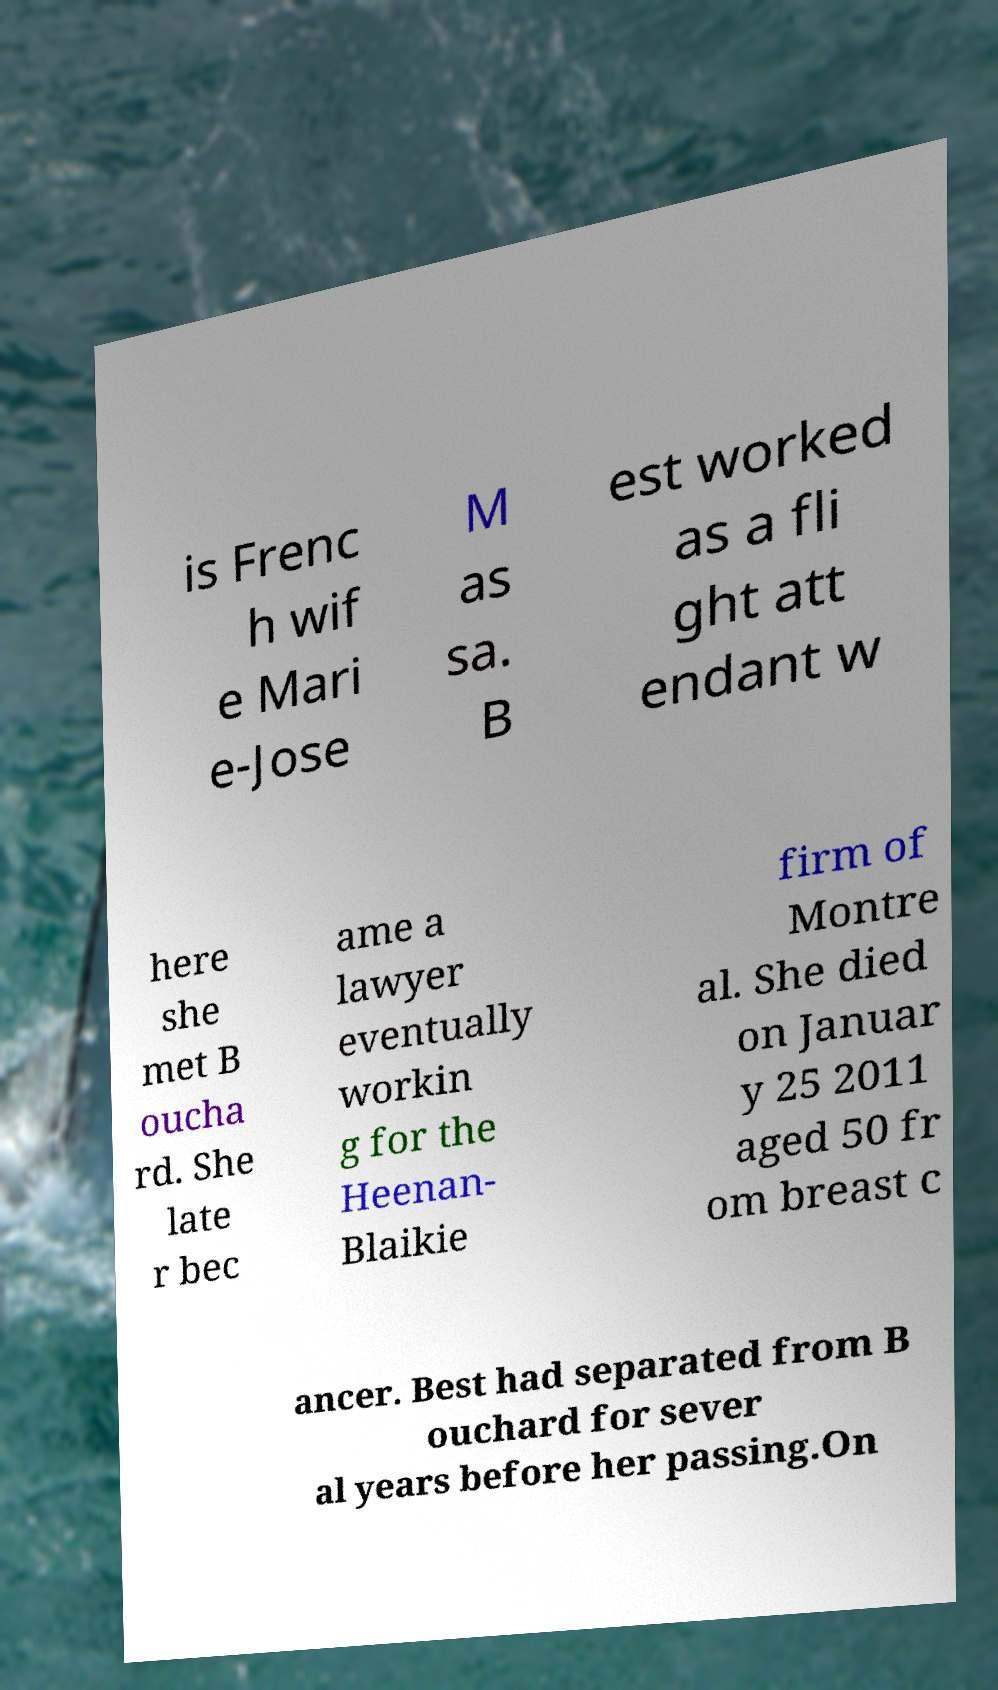Could you extract and type out the text from this image? is Frenc h wif e Mari e-Jose M as sa. B est worked as a fli ght att endant w here she met B oucha rd. She late r bec ame a lawyer eventually workin g for the Heenan- Blaikie firm of Montre al. She died on Januar y 25 2011 aged 50 fr om breast c ancer. Best had separated from B ouchard for sever al years before her passing.On 